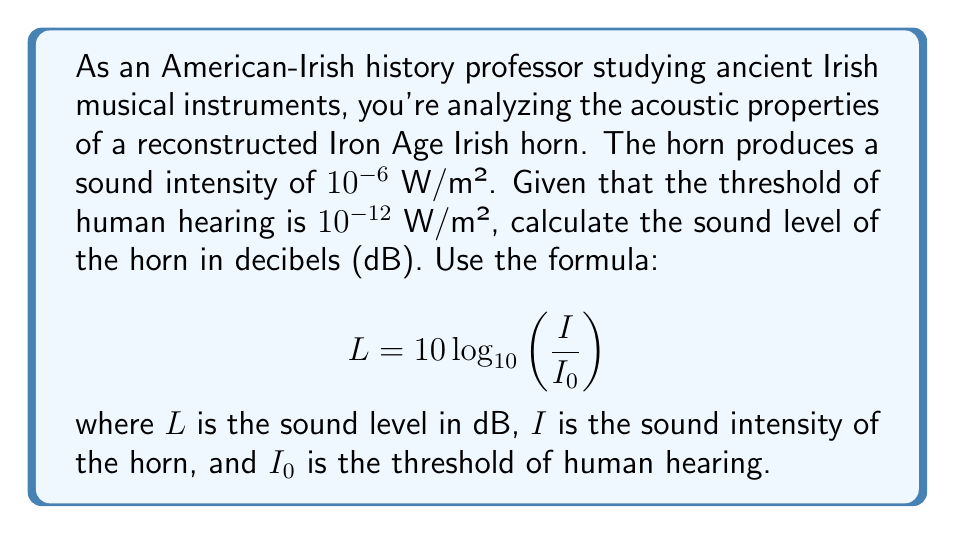Help me with this question. To solve this problem, we'll use the given formula and substitute the known values:

$$ L = 10 \log_{10}\left(\frac{I}{I_0}\right) $$

Where:
$I = 10^{-6}$ W/m² (sound intensity of the horn)
$I_0 = 10^{-12}$ W/m² (threshold of human hearing)

Let's substitute these values into the formula:

$$ L = 10 \log_{10}\left(\frac{10^{-6}}{10^{-12}}\right) $$

Now, we can simplify the fraction inside the logarithm:

$$ L = 10 \log_{10}(10^6) $$

Using the logarithm property $\log_a(x^n) = n\log_a(x)$, we get:

$$ L = 10 \cdot 6 \log_{10}(10) $$

Since $\log_{10}(10) = 1$, we have:

$$ L = 10 \cdot 6 \cdot 1 = 60 $$

Therefore, the sound level of the ancient Irish horn is 60 dB.
Answer: 60 dB 